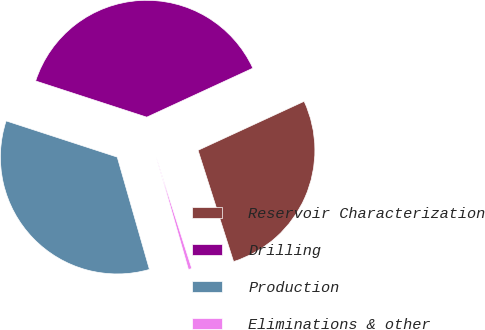<chart> <loc_0><loc_0><loc_500><loc_500><pie_chart><fcel>Reservoir Characterization<fcel>Drilling<fcel>Production<fcel>Eliminations & other<nl><fcel>26.96%<fcel>38.1%<fcel>34.45%<fcel>0.48%<nl></chart> 